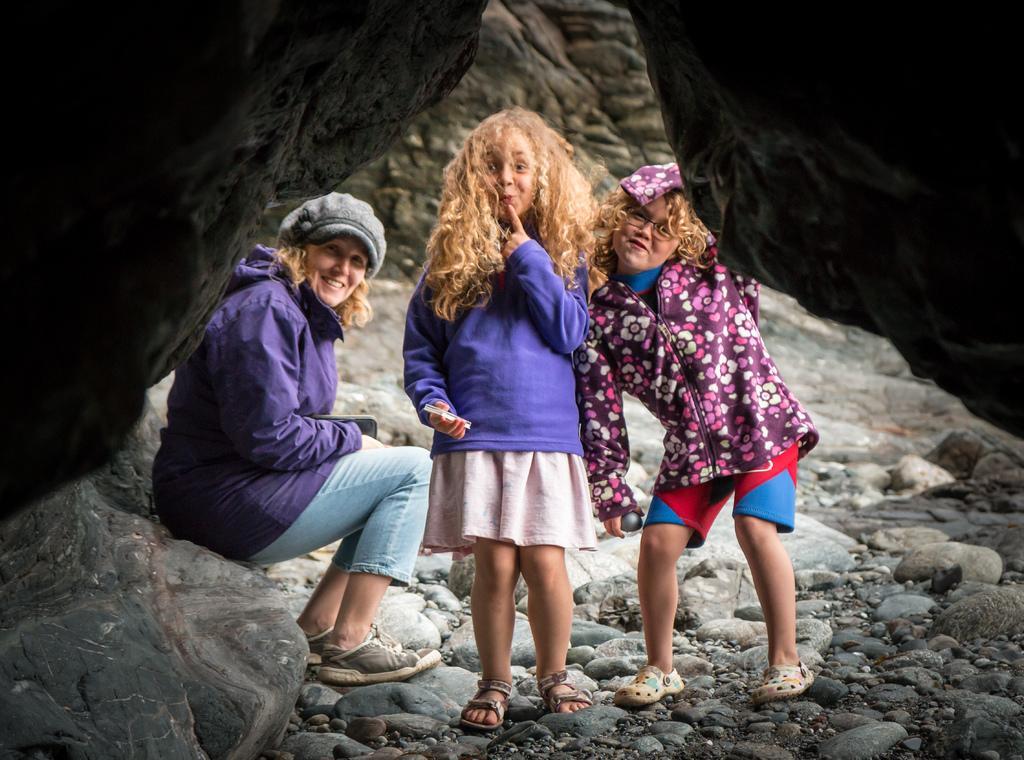Please provide a concise description of this image. There are people in the foreground area of the image on the stones, it seems like rocks in the top right and left side. 